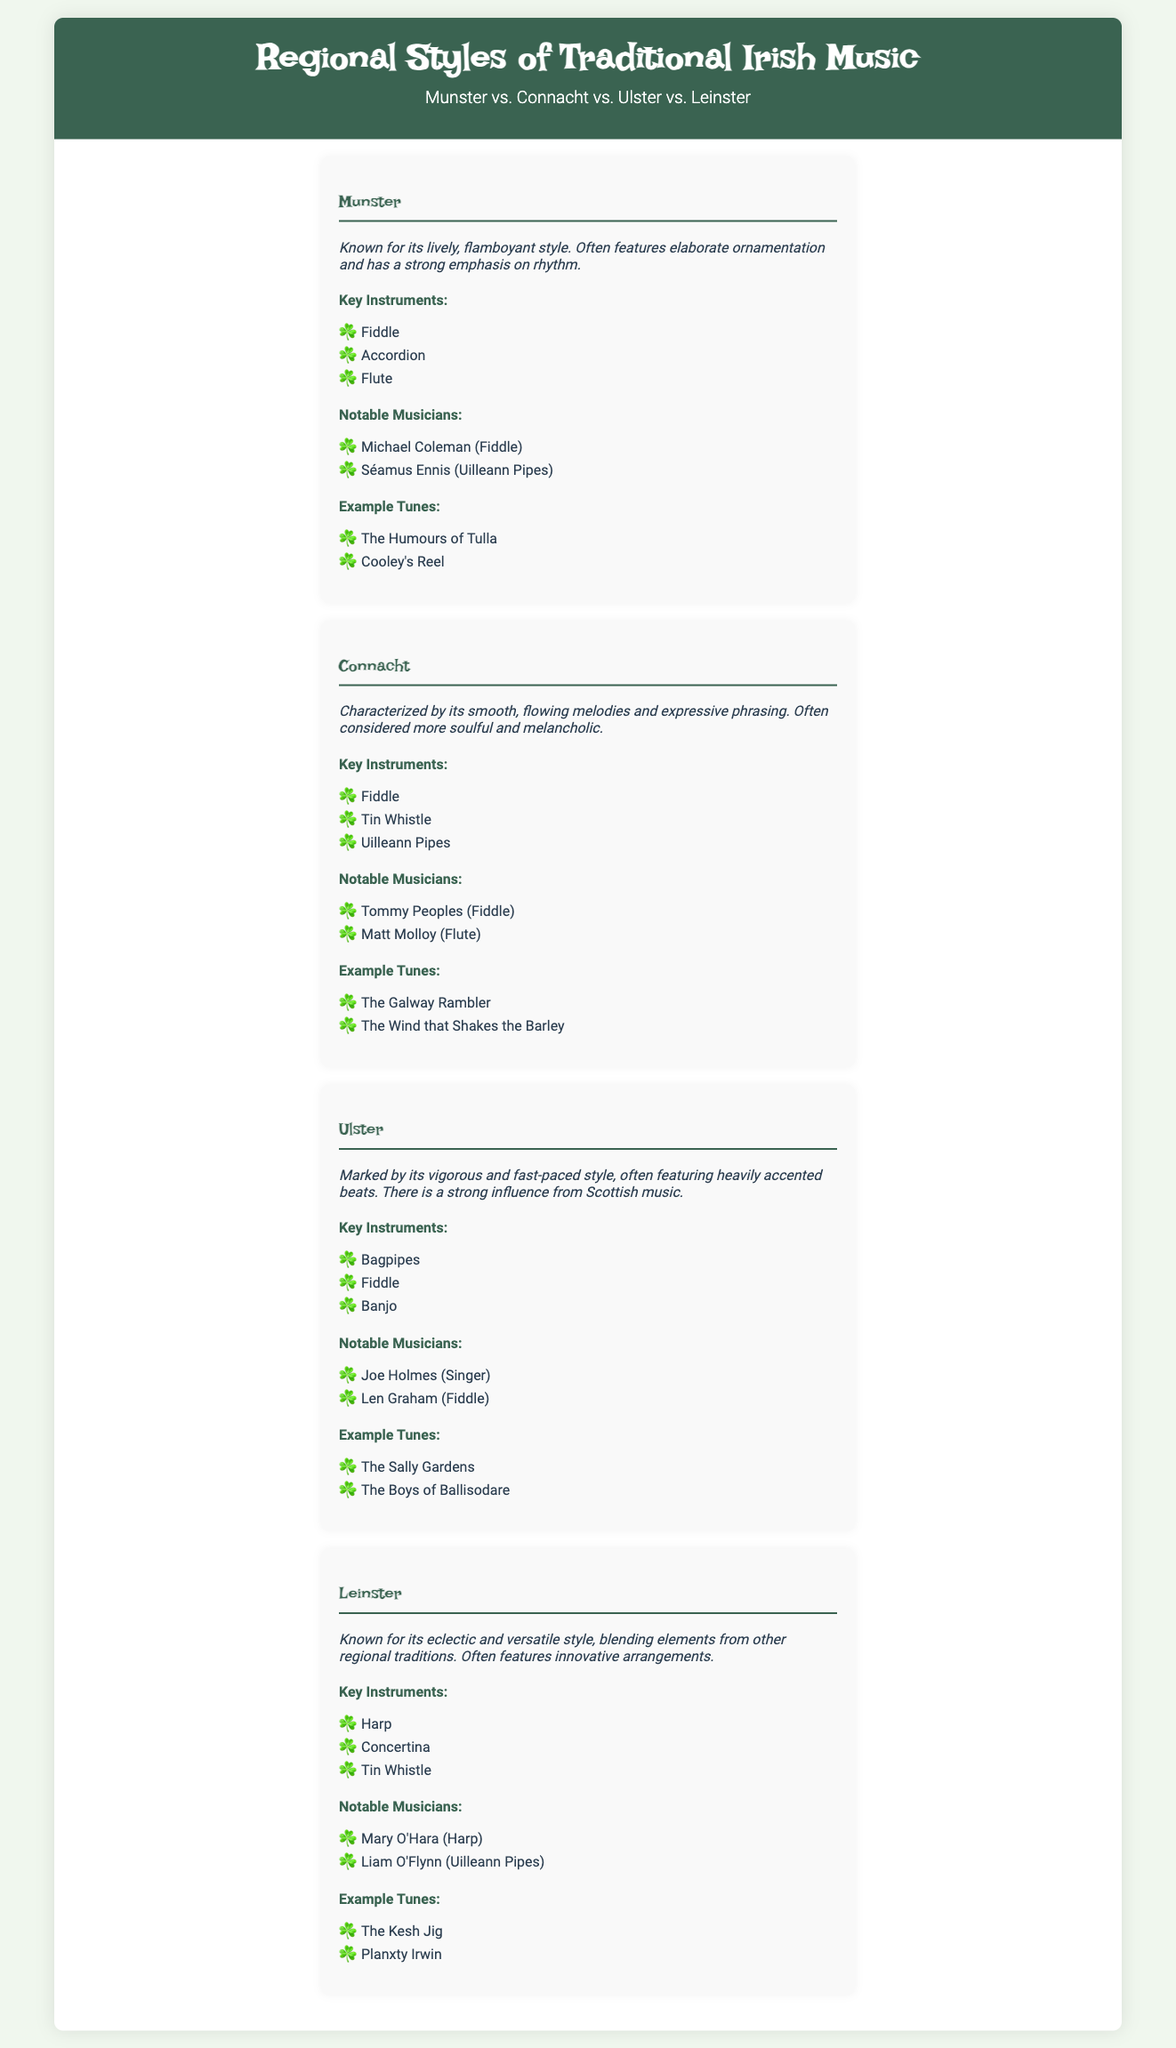What is the style characteristic of Munster? Munster is known for its lively, flamboyant style, featuring elaborate ornamentation and a strong emphasis on rhythm.
Answer: lively, flamboyant Who is a notable musician from Connacht? A notable musician from Connacht is Tommy Peoples, who plays the fiddle.
Answer: Tommy Peoples What key instrument is associated with Ulster music? Ulster music is associated with the bagpipes as one of its key instruments.
Answer: bagpipes What is the primary style of Leinster music? Leinster is known for its eclectic and versatile style, blending elements from other regional traditions.
Answer: eclectic and versatile Name an example tune from Munster. An example tune from Munster is "The Humours of Tulla."
Answer: The Humours of Tulla Which region features the tin whistle as a key instrument? Connacht features the tin whistle as a key instrument in its music.
Answer: Connacht How is Connacht's music often described? Connacht's music is often described as more soulful and melancholic.
Answer: soulful and melancholic What influence is noted in Ulster music? Ulster music shows a strong influence from Scottish music.
Answer: Scottish music How many regions are compared in the infographic? The infographic compares four regions of traditional Irish music.
Answer: four 